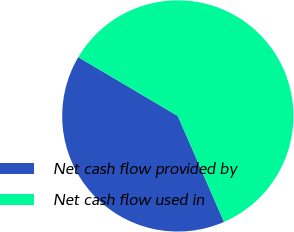<chart> <loc_0><loc_0><loc_500><loc_500><pie_chart><fcel>Net cash flow provided by<fcel>Net cash flow used in<nl><fcel>40.04%<fcel>59.96%<nl></chart> 